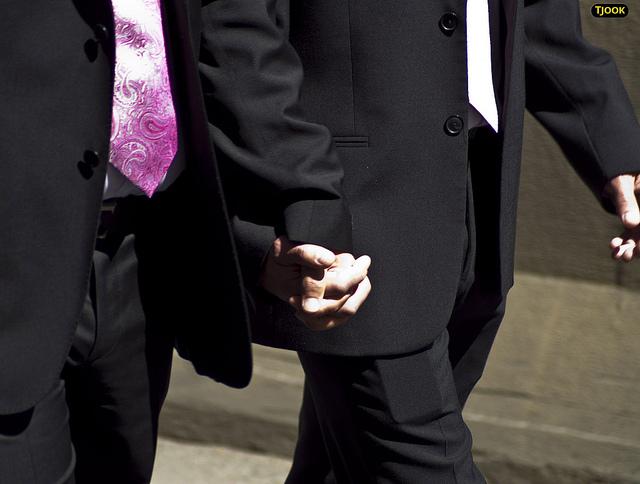What color are the men's pants?
Quick response, please. Black. Where is the pink tie?
Be succinct. On left. Is there a suit in this picture?
Answer briefly. Yes. 